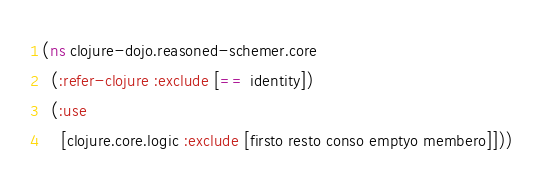<code> <loc_0><loc_0><loc_500><loc_500><_Clojure_>(ns clojure-dojo.reasoned-schemer.core
  (:refer-clojure :exclude [== identity])
  (:use
    [clojure.core.logic :exclude [firsto resto conso emptyo membero]]))
</code> 